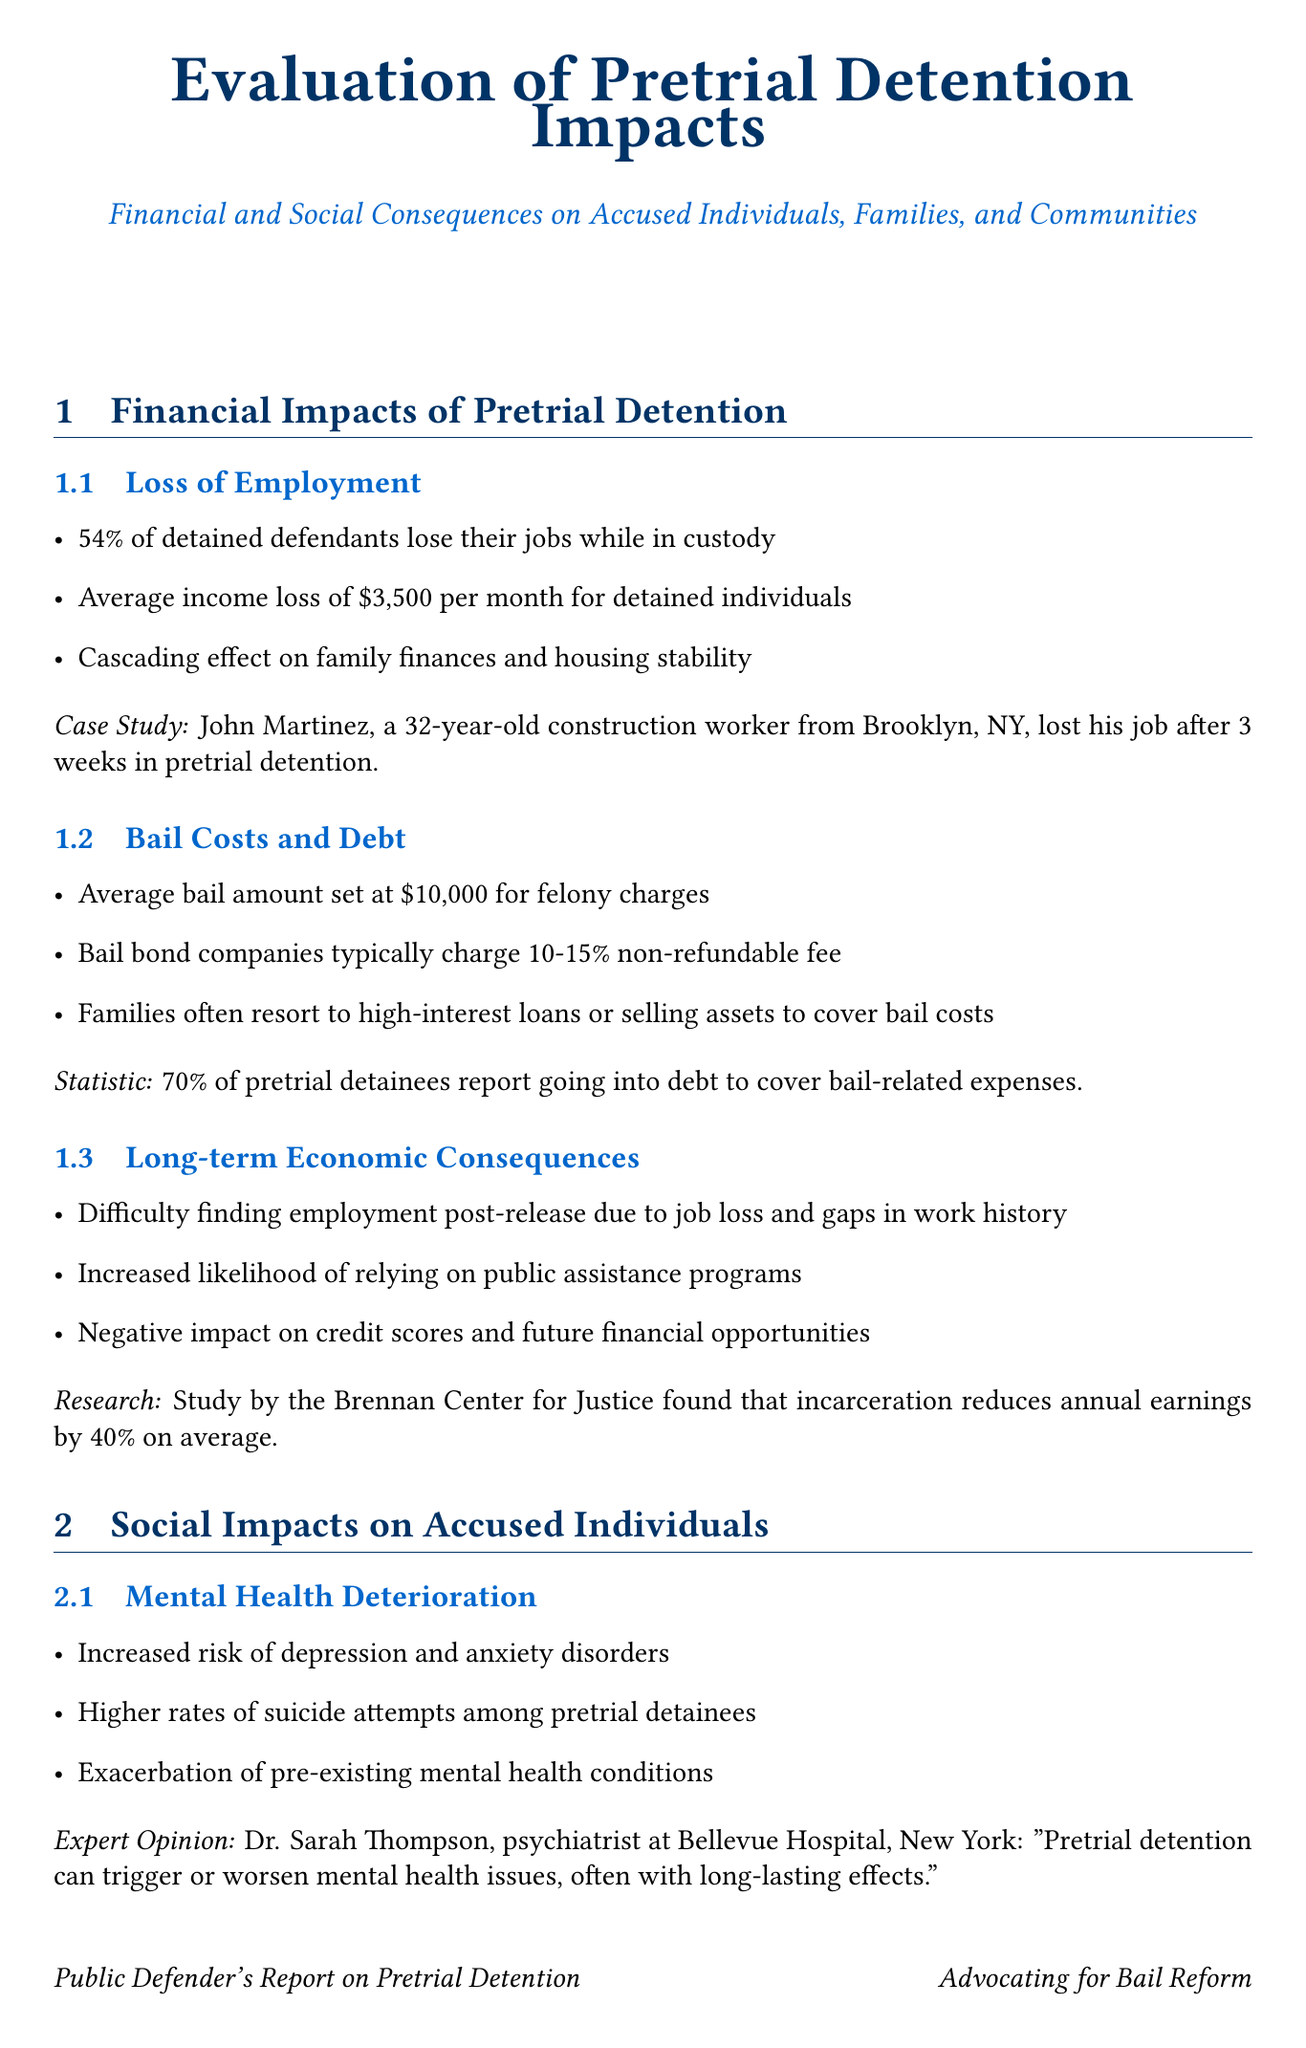what percentage of detained defendants lose their jobs while in custody? The report states that 54% of detained defendants lose their jobs while in custody.
Answer: 54% what is the average income loss per month for detained individuals? The average income loss for detained individuals is presented as $3,500 per month.
Answer: $3,500 how much does the average bail amount worth for felony charges? The document notes that the average bail amount set for felony charges is $10,000.
Answer: $10,000 what percentage of pretrial detainees report going into debt for bail-related expenses? According to the report, 70% of pretrial detainees report going into debt to cover bail-related expenses.
Answer: 70% what is the projected annual savings with a 50% reduction in pretrial detention? The report indicates projected annual savings of $467 million with a 50% reduction in pretrial detention.
Answer: $467 million what is the estimated annual economic loss to communities due to pretrial detention? The Urban Institute study estimates that communities lose $13 billion annually due to pretrial detention.
Answer: $13 billion who stated that pretrial detention can trigger or worsen mental health issues? The document references Dr. Sarah Thompson, psychiatrist at Bellevue Hospital, New York.
Answer: Dr. Sarah Thompson how many times more likely are detained defendants to plead guilty compared to those released pretrial? The statistic reveals that detained defendants are 9 times more likely to plead guilty than those released pretrial.
Answer: 9 times what issue do 60% of clients from Bronx Defenders experience due to pretrial detention? The Bronx Defenders report indicates that 60% of their clients experience disruptions in medical care due to pretrial detention.
Answer: disruptions in medical care what percentage court appearance rate does Washington, D.C.'s Pretrial Services Agency achieve? The report states that Washington, D.C.'s Pretrial Services Agency achieves an 88% court appearance rate.
Answer: 88% 